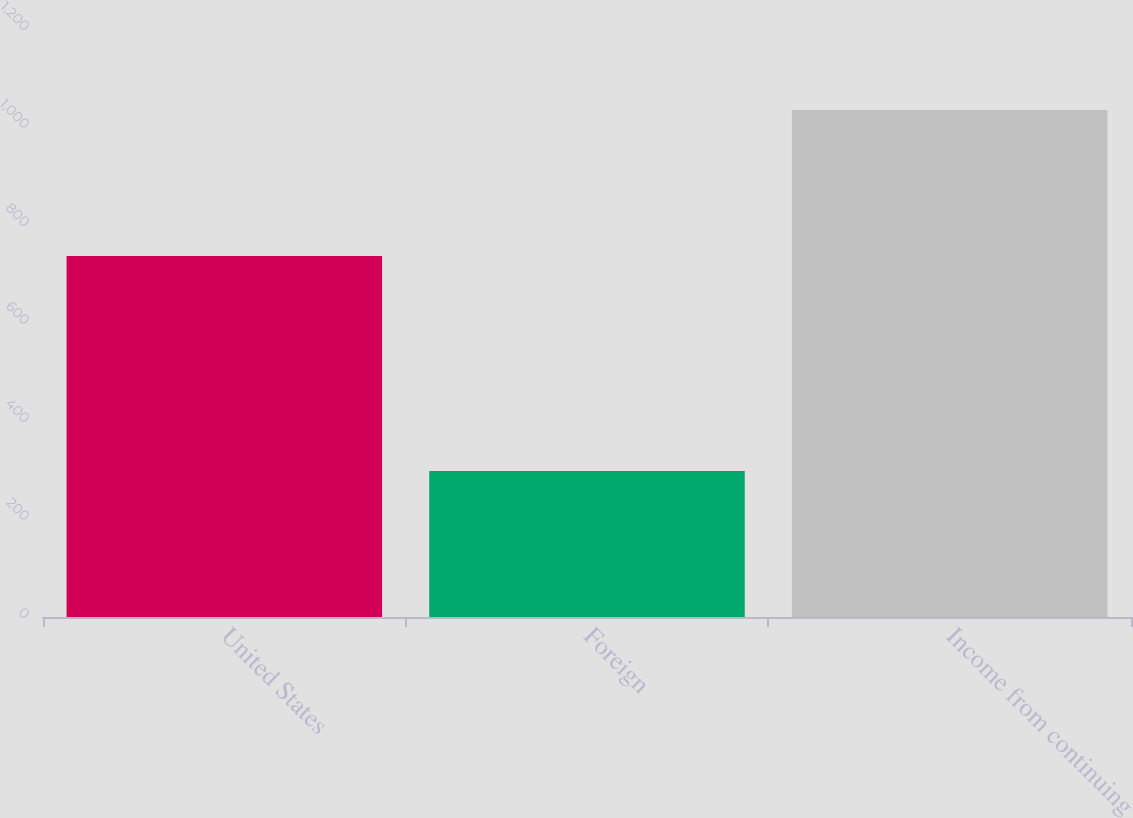<chart> <loc_0><loc_0><loc_500><loc_500><bar_chart><fcel>United States<fcel>Foreign<fcel>Income from continuing<nl><fcel>736.7<fcel>298.1<fcel>1034.8<nl></chart> 